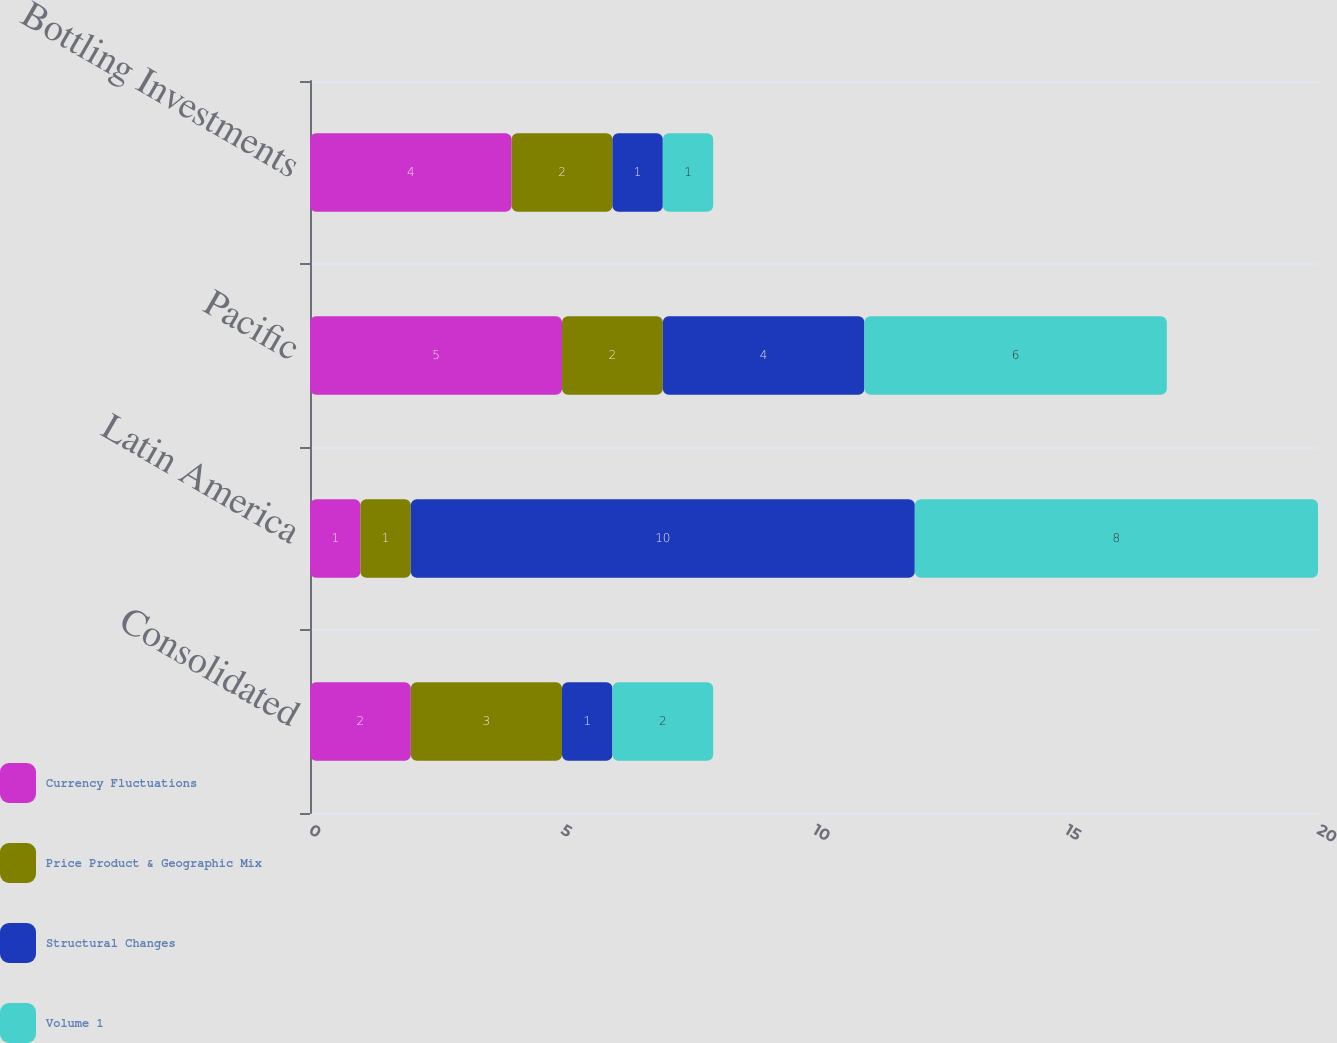Convert chart. <chart><loc_0><loc_0><loc_500><loc_500><stacked_bar_chart><ecel><fcel>Consolidated<fcel>Latin America<fcel>Pacific<fcel>Bottling Investments<nl><fcel>Currency Fluctuations<fcel>2<fcel>1<fcel>5<fcel>4<nl><fcel>Price Product & Geographic Mix<fcel>3<fcel>1<fcel>2<fcel>2<nl><fcel>Structural Changes<fcel>1<fcel>10<fcel>4<fcel>1<nl><fcel>Volume 1<fcel>2<fcel>8<fcel>6<fcel>1<nl></chart> 